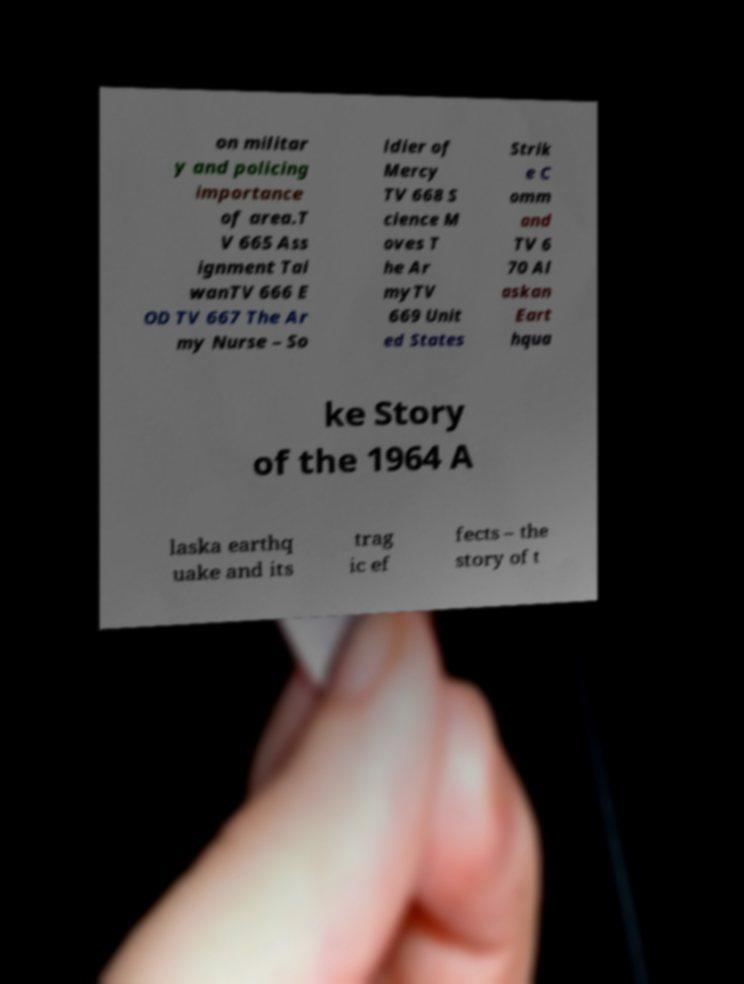Please identify and transcribe the text found in this image. on militar y and policing importance of area.T V 665 Ass ignment Tai wanTV 666 E OD TV 667 The Ar my Nurse – So ldier of Mercy TV 668 S cience M oves T he Ar myTV 669 Unit ed States Strik e C omm and TV 6 70 Al askan Eart hqua ke Story of the 1964 A laska earthq uake and its trag ic ef fects – the story of t 